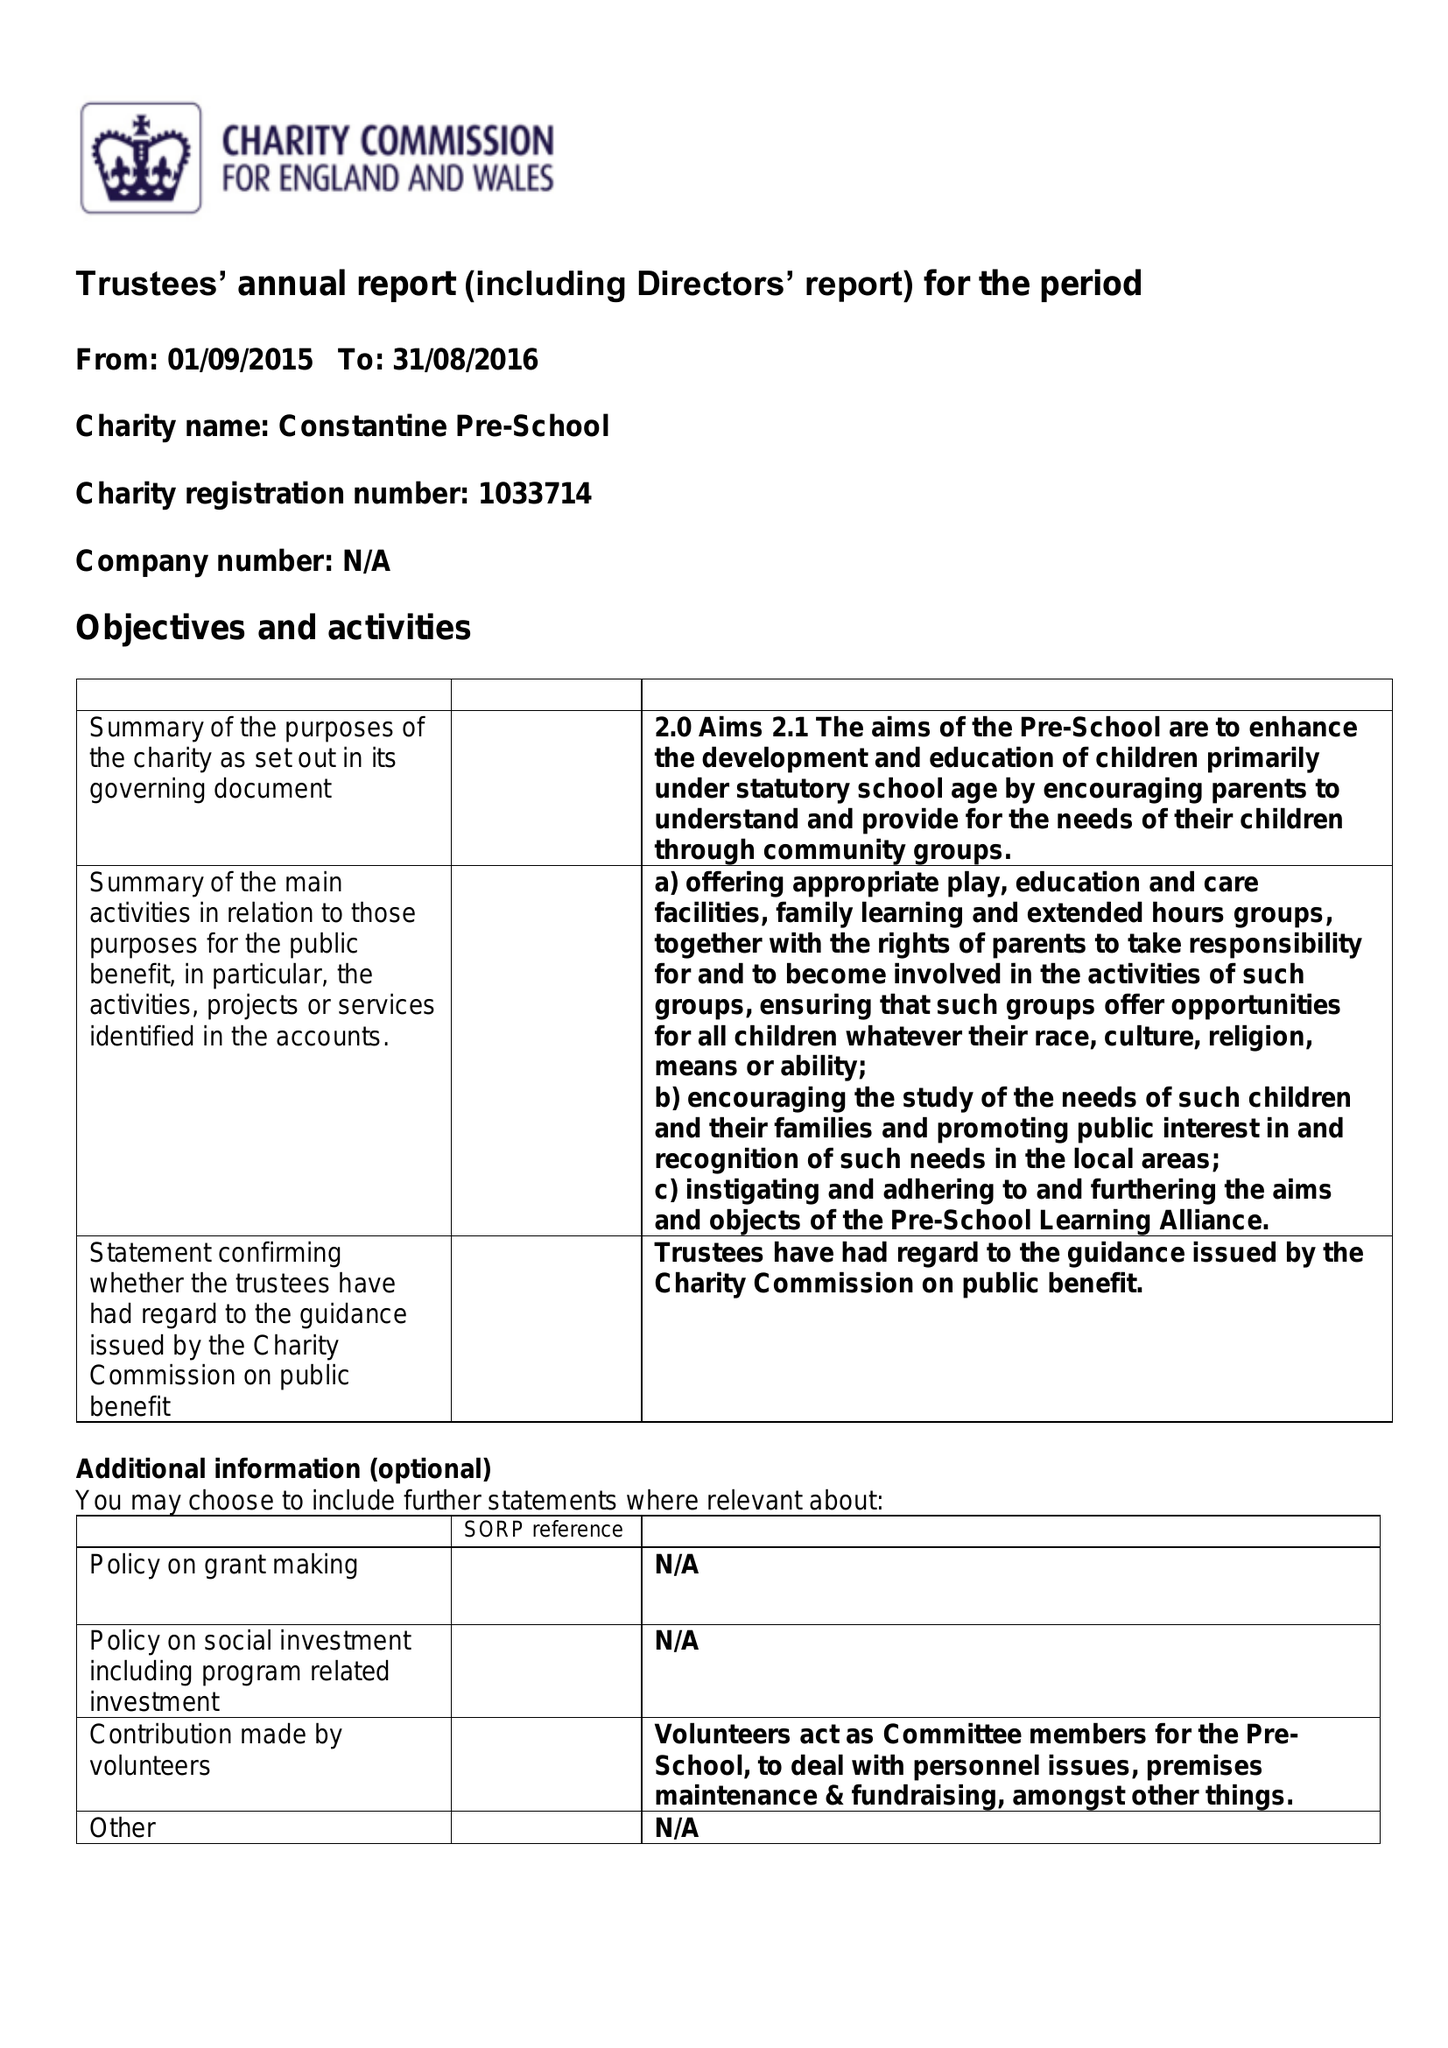What is the value for the address__postcode?
Answer the question using a single word or phrase. TR11 5AG 